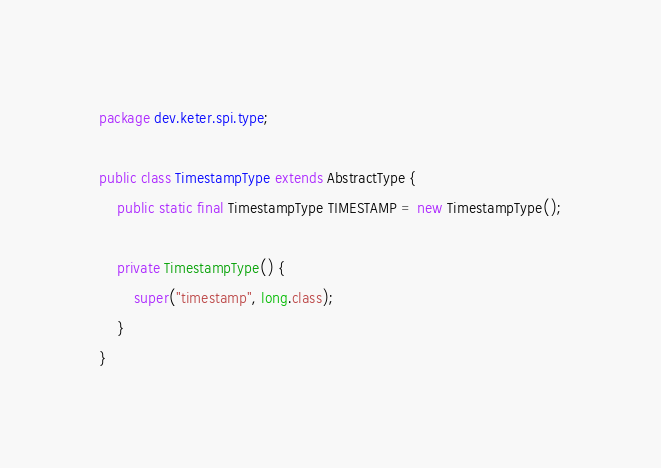Convert code to text. <code><loc_0><loc_0><loc_500><loc_500><_Java_>package dev.keter.spi.type;

public class TimestampType extends AbstractType {
    public static final TimestampType TIMESTAMP = new TimestampType();

    private TimestampType() {
        super("timestamp", long.class);
    }
}
</code> 